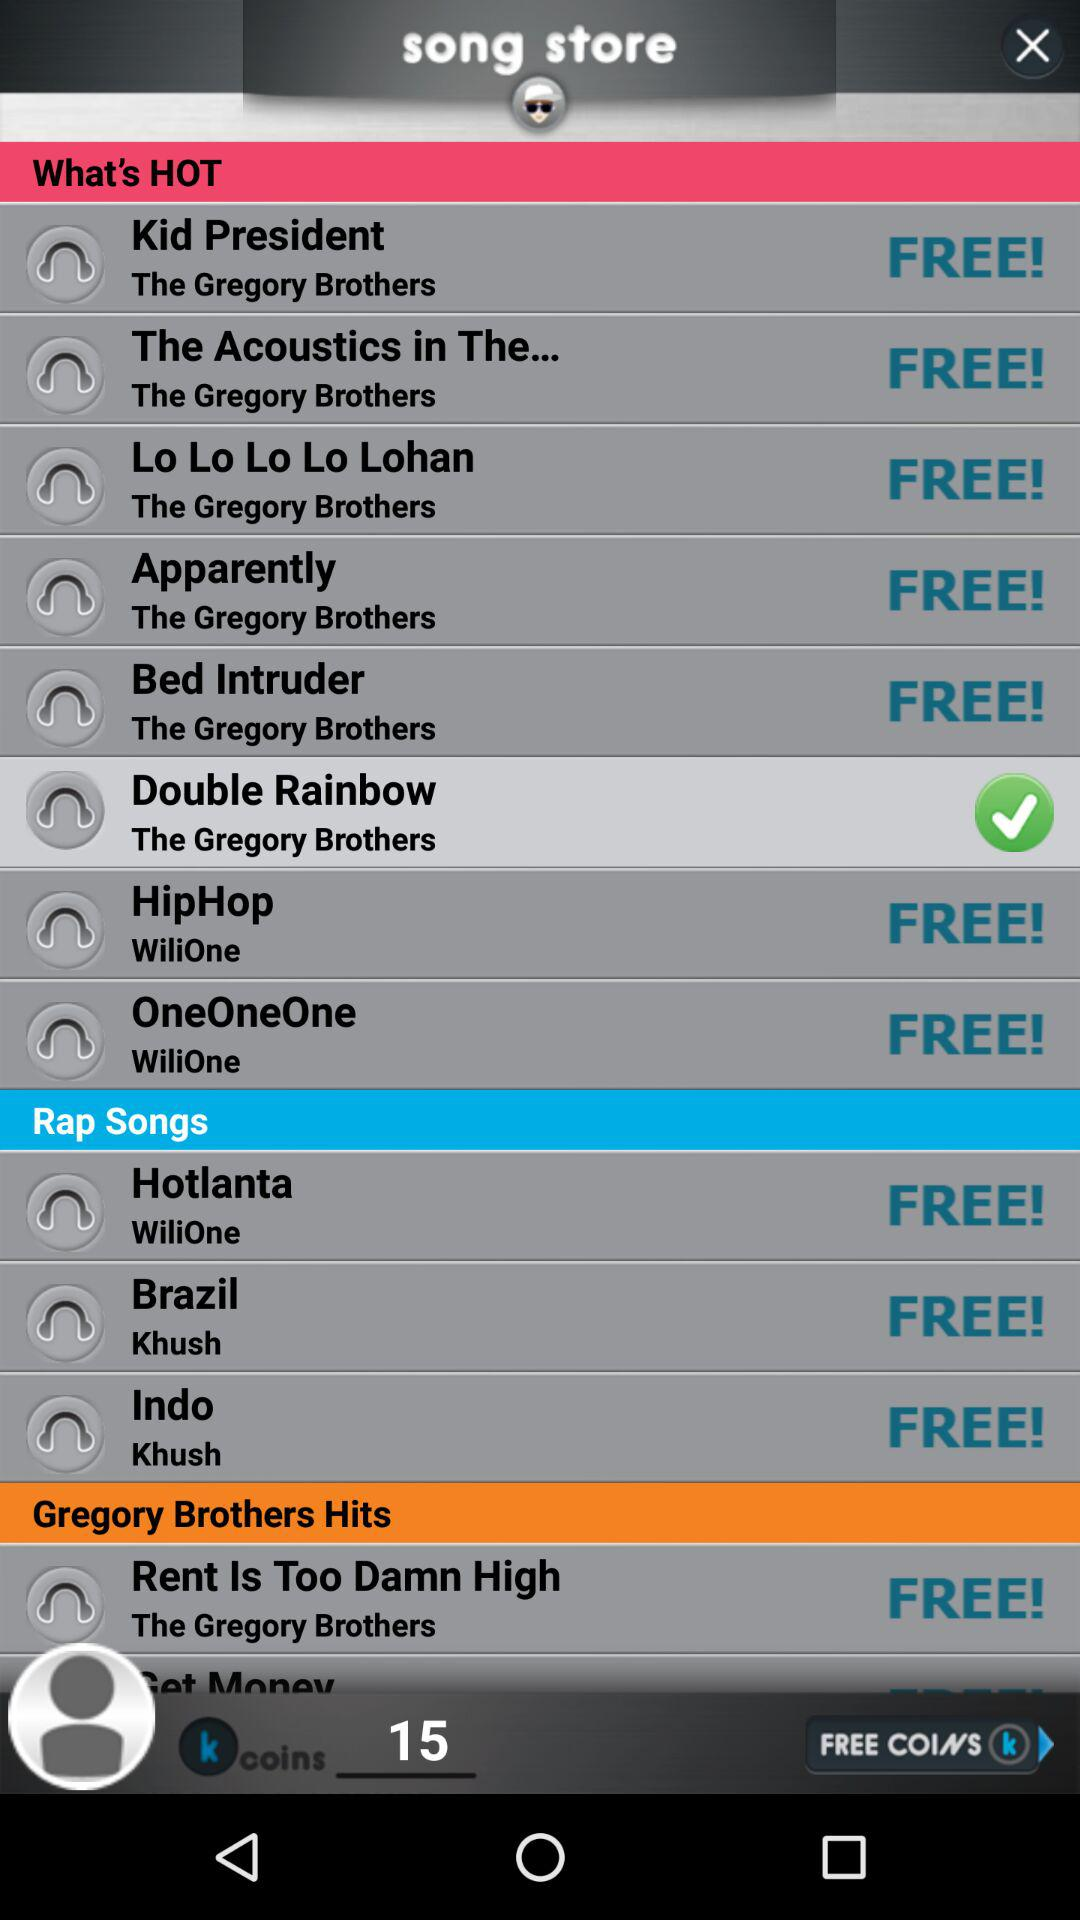Which song is selected? The selected song is "Double Rainbow". 